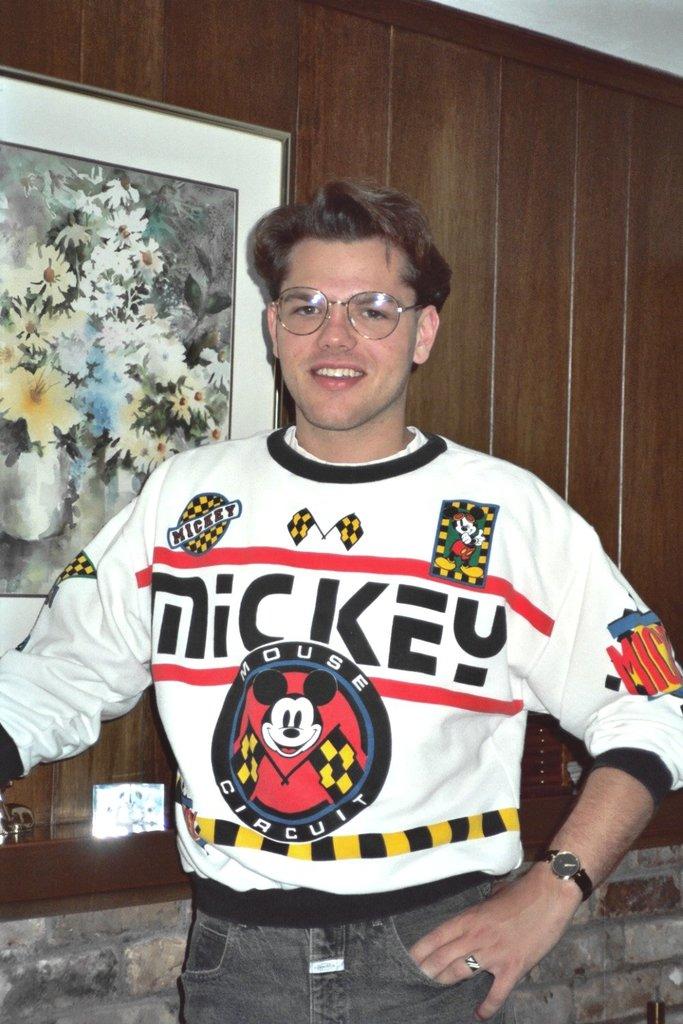What name is at the top of the sweater?
Offer a terse response. Mickey. What is written in the circle around mickey?
Ensure brevity in your answer.  Mouse circuit. 